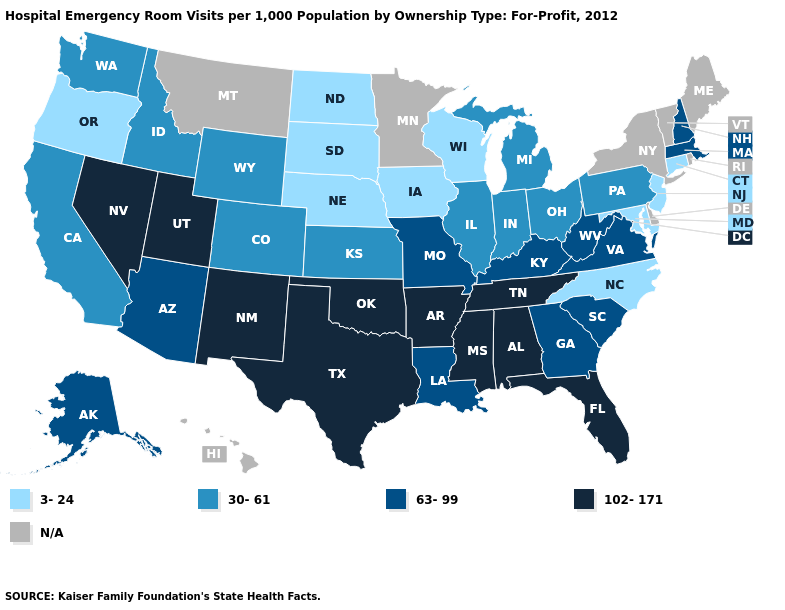What is the value of Missouri?
Be succinct. 63-99. What is the value of West Virginia?
Answer briefly. 63-99. What is the value of Hawaii?
Short answer required. N/A. Is the legend a continuous bar?
Keep it brief. No. Which states hav the highest value in the Northeast?
Concise answer only. Massachusetts, New Hampshire. Does Oregon have the lowest value in the West?
Be succinct. Yes. Name the states that have a value in the range 102-171?
Give a very brief answer. Alabama, Arkansas, Florida, Mississippi, Nevada, New Mexico, Oklahoma, Tennessee, Texas, Utah. Name the states that have a value in the range N/A?
Answer briefly. Delaware, Hawaii, Maine, Minnesota, Montana, New York, Rhode Island, Vermont. Does the map have missing data?
Answer briefly. Yes. Name the states that have a value in the range 102-171?
Give a very brief answer. Alabama, Arkansas, Florida, Mississippi, Nevada, New Mexico, Oklahoma, Tennessee, Texas, Utah. Does South Dakota have the lowest value in the USA?
Short answer required. Yes. Name the states that have a value in the range 3-24?
Answer briefly. Connecticut, Iowa, Maryland, Nebraska, New Jersey, North Carolina, North Dakota, Oregon, South Dakota, Wisconsin. What is the value of Michigan?
Keep it brief. 30-61. 